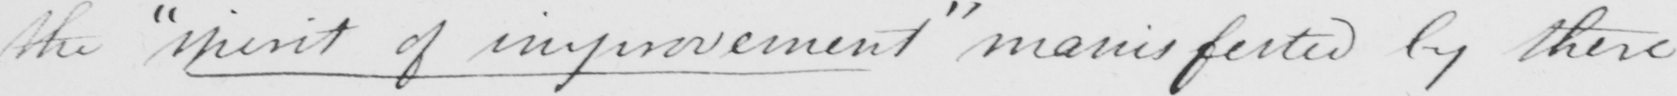Transcribe the text shown in this historical manuscript line. the  " spirit of improvement "  manifested by there 